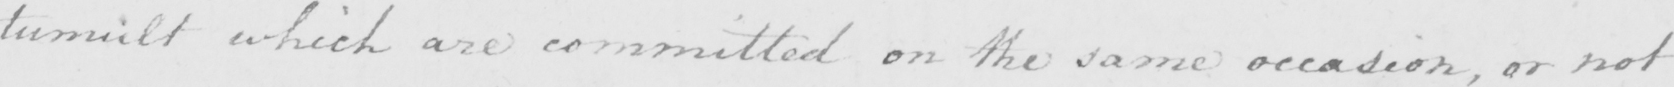What is written in this line of handwriting? tumult which are committed on the same occasion, or not 